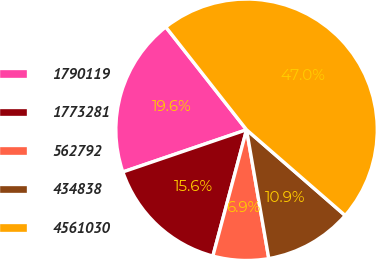<chart> <loc_0><loc_0><loc_500><loc_500><pie_chart><fcel>1790119<fcel>1773281<fcel>562792<fcel>434838<fcel>4561030<nl><fcel>19.63%<fcel>15.62%<fcel>6.87%<fcel>10.89%<fcel>46.99%<nl></chart> 